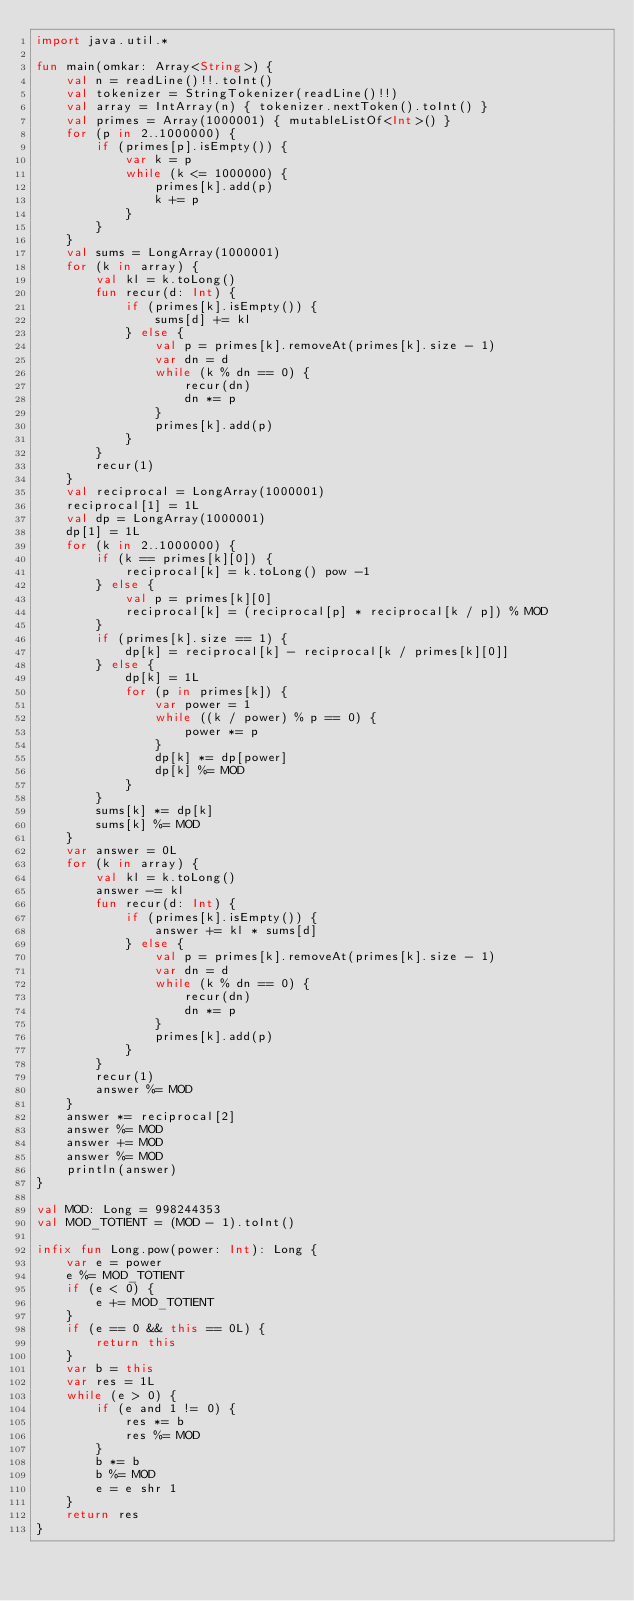Convert code to text. <code><loc_0><loc_0><loc_500><loc_500><_Kotlin_>import java.util.*

fun main(omkar: Array<String>) {
    val n = readLine()!!.toInt()
    val tokenizer = StringTokenizer(readLine()!!)
    val array = IntArray(n) { tokenizer.nextToken().toInt() }
    val primes = Array(1000001) { mutableListOf<Int>() }
    for (p in 2..1000000) {
        if (primes[p].isEmpty()) {
            var k = p
            while (k <= 1000000) {
                primes[k].add(p)
                k += p
            }
        }
    }
    val sums = LongArray(1000001)
    for (k in array) {
        val kl = k.toLong()
        fun recur(d: Int) {
            if (primes[k].isEmpty()) {
                sums[d] += kl
            } else {
                val p = primes[k].removeAt(primes[k].size - 1)
                var dn = d
                while (k % dn == 0) {
                    recur(dn)
                    dn *= p
                }
                primes[k].add(p)
            }
        }
        recur(1)
    }
    val reciprocal = LongArray(1000001)
    reciprocal[1] = 1L
    val dp = LongArray(1000001)
    dp[1] = 1L
    for (k in 2..1000000) {
        if (k == primes[k][0]) {
            reciprocal[k] = k.toLong() pow -1
        } else {
            val p = primes[k][0]
            reciprocal[k] = (reciprocal[p] * reciprocal[k / p]) % MOD
        }
        if (primes[k].size == 1) {
            dp[k] = reciprocal[k] - reciprocal[k / primes[k][0]]
        } else {
            dp[k] = 1L
            for (p in primes[k]) {
                var power = 1
                while ((k / power) % p == 0) {
                    power *= p
                }
                dp[k] *= dp[power]
                dp[k] %= MOD
            }
        }
        sums[k] *= dp[k]
        sums[k] %= MOD
    }
    var answer = 0L
    for (k in array) {
        val kl = k.toLong()
        answer -= kl
        fun recur(d: Int) {
            if (primes[k].isEmpty()) {
                answer += kl * sums[d]
            } else {
                val p = primes[k].removeAt(primes[k].size - 1)
                var dn = d
                while (k % dn == 0) {
                    recur(dn)
                    dn *= p
                }
                primes[k].add(p)
            }
        }
        recur(1)
        answer %= MOD
    }
    answer *= reciprocal[2]
    answer %= MOD
    answer += MOD
    answer %= MOD
    println(answer)
}

val MOD: Long = 998244353
val MOD_TOTIENT = (MOD - 1).toInt()

infix fun Long.pow(power: Int): Long {
    var e = power
    e %= MOD_TOTIENT
    if (e < 0) {
        e += MOD_TOTIENT
    }
    if (e == 0 && this == 0L) {
        return this
    }
    var b = this
    var res = 1L
    while (e > 0) {
        if (e and 1 != 0) {
            res *= b
            res %= MOD
        }
        b *= b
        b %= MOD
        e = e shr 1
    }
    return res
}</code> 